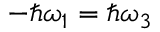Convert formula to latex. <formula><loc_0><loc_0><loc_500><loc_500>- \hbar { \omega } _ { 1 } = \hbar { \omega } _ { 3 }</formula> 